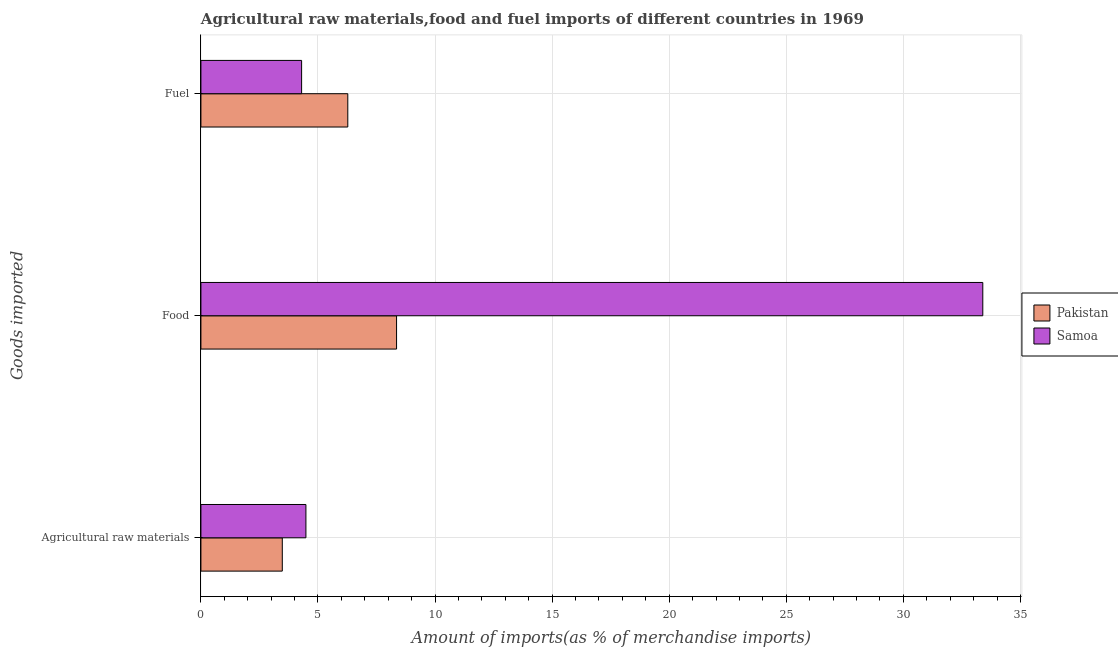Are the number of bars per tick equal to the number of legend labels?
Give a very brief answer. Yes. How many bars are there on the 1st tick from the bottom?
Keep it short and to the point. 2. What is the label of the 1st group of bars from the top?
Ensure brevity in your answer.  Fuel. What is the percentage of raw materials imports in Pakistan?
Make the answer very short. 3.48. Across all countries, what is the maximum percentage of raw materials imports?
Keep it short and to the point. 4.48. Across all countries, what is the minimum percentage of raw materials imports?
Offer a terse response. 3.48. In which country was the percentage of food imports minimum?
Offer a terse response. Pakistan. What is the total percentage of fuel imports in the graph?
Give a very brief answer. 10.57. What is the difference between the percentage of fuel imports in Samoa and that in Pakistan?
Provide a short and direct response. -1.97. What is the difference between the percentage of food imports in Pakistan and the percentage of raw materials imports in Samoa?
Your answer should be compact. 3.87. What is the average percentage of fuel imports per country?
Provide a short and direct response. 5.29. What is the difference between the percentage of raw materials imports and percentage of food imports in Samoa?
Your response must be concise. -28.91. What is the ratio of the percentage of fuel imports in Pakistan to that in Samoa?
Offer a very short reply. 1.46. What is the difference between the highest and the second highest percentage of raw materials imports?
Give a very brief answer. 1.01. What is the difference between the highest and the lowest percentage of raw materials imports?
Your response must be concise. 1.01. Is the sum of the percentage of raw materials imports in Samoa and Pakistan greater than the maximum percentage of fuel imports across all countries?
Your response must be concise. Yes. What does the 1st bar from the top in Fuel represents?
Provide a short and direct response. Samoa. What does the 1st bar from the bottom in Food represents?
Provide a succinct answer. Pakistan. Is it the case that in every country, the sum of the percentage of raw materials imports and percentage of food imports is greater than the percentage of fuel imports?
Your answer should be very brief. Yes. How many bars are there?
Offer a terse response. 6. Are all the bars in the graph horizontal?
Provide a succinct answer. Yes. How many countries are there in the graph?
Keep it short and to the point. 2. What is the difference between two consecutive major ticks on the X-axis?
Offer a terse response. 5. How are the legend labels stacked?
Offer a terse response. Vertical. What is the title of the graph?
Ensure brevity in your answer.  Agricultural raw materials,food and fuel imports of different countries in 1969. What is the label or title of the X-axis?
Provide a short and direct response. Amount of imports(as % of merchandise imports). What is the label or title of the Y-axis?
Make the answer very short. Goods imported. What is the Amount of imports(as % of merchandise imports) of Pakistan in Agricultural raw materials?
Make the answer very short. 3.48. What is the Amount of imports(as % of merchandise imports) in Samoa in Agricultural raw materials?
Offer a terse response. 4.48. What is the Amount of imports(as % of merchandise imports) in Pakistan in Food?
Provide a short and direct response. 8.36. What is the Amount of imports(as % of merchandise imports) in Samoa in Food?
Your answer should be compact. 33.39. What is the Amount of imports(as % of merchandise imports) of Pakistan in Fuel?
Provide a short and direct response. 6.27. What is the Amount of imports(as % of merchandise imports) in Samoa in Fuel?
Give a very brief answer. 4.3. Across all Goods imported, what is the maximum Amount of imports(as % of merchandise imports) in Pakistan?
Your answer should be compact. 8.36. Across all Goods imported, what is the maximum Amount of imports(as % of merchandise imports) of Samoa?
Provide a short and direct response. 33.39. Across all Goods imported, what is the minimum Amount of imports(as % of merchandise imports) of Pakistan?
Offer a terse response. 3.48. Across all Goods imported, what is the minimum Amount of imports(as % of merchandise imports) of Samoa?
Your answer should be very brief. 4.3. What is the total Amount of imports(as % of merchandise imports) of Pakistan in the graph?
Make the answer very short. 18.1. What is the total Amount of imports(as % of merchandise imports) of Samoa in the graph?
Give a very brief answer. 42.18. What is the difference between the Amount of imports(as % of merchandise imports) of Pakistan in Agricultural raw materials and that in Food?
Keep it short and to the point. -4.88. What is the difference between the Amount of imports(as % of merchandise imports) of Samoa in Agricultural raw materials and that in Food?
Provide a short and direct response. -28.91. What is the difference between the Amount of imports(as % of merchandise imports) of Pakistan in Agricultural raw materials and that in Fuel?
Your answer should be compact. -2.8. What is the difference between the Amount of imports(as % of merchandise imports) in Samoa in Agricultural raw materials and that in Fuel?
Ensure brevity in your answer.  0.18. What is the difference between the Amount of imports(as % of merchandise imports) of Pakistan in Food and that in Fuel?
Offer a very short reply. 2.08. What is the difference between the Amount of imports(as % of merchandise imports) in Samoa in Food and that in Fuel?
Your answer should be very brief. 29.09. What is the difference between the Amount of imports(as % of merchandise imports) in Pakistan in Agricultural raw materials and the Amount of imports(as % of merchandise imports) in Samoa in Food?
Your answer should be compact. -29.92. What is the difference between the Amount of imports(as % of merchandise imports) in Pakistan in Agricultural raw materials and the Amount of imports(as % of merchandise imports) in Samoa in Fuel?
Offer a terse response. -0.83. What is the difference between the Amount of imports(as % of merchandise imports) of Pakistan in Food and the Amount of imports(as % of merchandise imports) of Samoa in Fuel?
Ensure brevity in your answer.  4.05. What is the average Amount of imports(as % of merchandise imports) in Pakistan per Goods imported?
Keep it short and to the point. 6.03. What is the average Amount of imports(as % of merchandise imports) in Samoa per Goods imported?
Your response must be concise. 14.06. What is the difference between the Amount of imports(as % of merchandise imports) in Pakistan and Amount of imports(as % of merchandise imports) in Samoa in Agricultural raw materials?
Keep it short and to the point. -1.01. What is the difference between the Amount of imports(as % of merchandise imports) of Pakistan and Amount of imports(as % of merchandise imports) of Samoa in Food?
Your answer should be compact. -25.04. What is the difference between the Amount of imports(as % of merchandise imports) of Pakistan and Amount of imports(as % of merchandise imports) of Samoa in Fuel?
Your response must be concise. 1.97. What is the ratio of the Amount of imports(as % of merchandise imports) of Pakistan in Agricultural raw materials to that in Food?
Give a very brief answer. 0.42. What is the ratio of the Amount of imports(as % of merchandise imports) in Samoa in Agricultural raw materials to that in Food?
Give a very brief answer. 0.13. What is the ratio of the Amount of imports(as % of merchandise imports) of Pakistan in Agricultural raw materials to that in Fuel?
Offer a terse response. 0.55. What is the ratio of the Amount of imports(as % of merchandise imports) of Samoa in Agricultural raw materials to that in Fuel?
Provide a succinct answer. 1.04. What is the ratio of the Amount of imports(as % of merchandise imports) in Pakistan in Food to that in Fuel?
Make the answer very short. 1.33. What is the ratio of the Amount of imports(as % of merchandise imports) of Samoa in Food to that in Fuel?
Ensure brevity in your answer.  7.76. What is the difference between the highest and the second highest Amount of imports(as % of merchandise imports) in Pakistan?
Ensure brevity in your answer.  2.08. What is the difference between the highest and the second highest Amount of imports(as % of merchandise imports) of Samoa?
Provide a short and direct response. 28.91. What is the difference between the highest and the lowest Amount of imports(as % of merchandise imports) in Pakistan?
Give a very brief answer. 4.88. What is the difference between the highest and the lowest Amount of imports(as % of merchandise imports) of Samoa?
Your answer should be very brief. 29.09. 